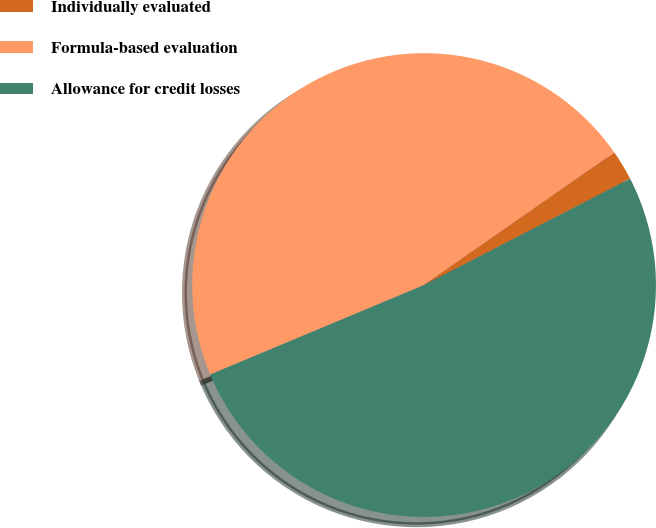<chart> <loc_0><loc_0><loc_500><loc_500><pie_chart><fcel>Individually evaluated<fcel>Formula-based evaluation<fcel>Allowance for credit losses<nl><fcel>2.09%<fcel>46.63%<fcel>51.29%<nl></chart> 